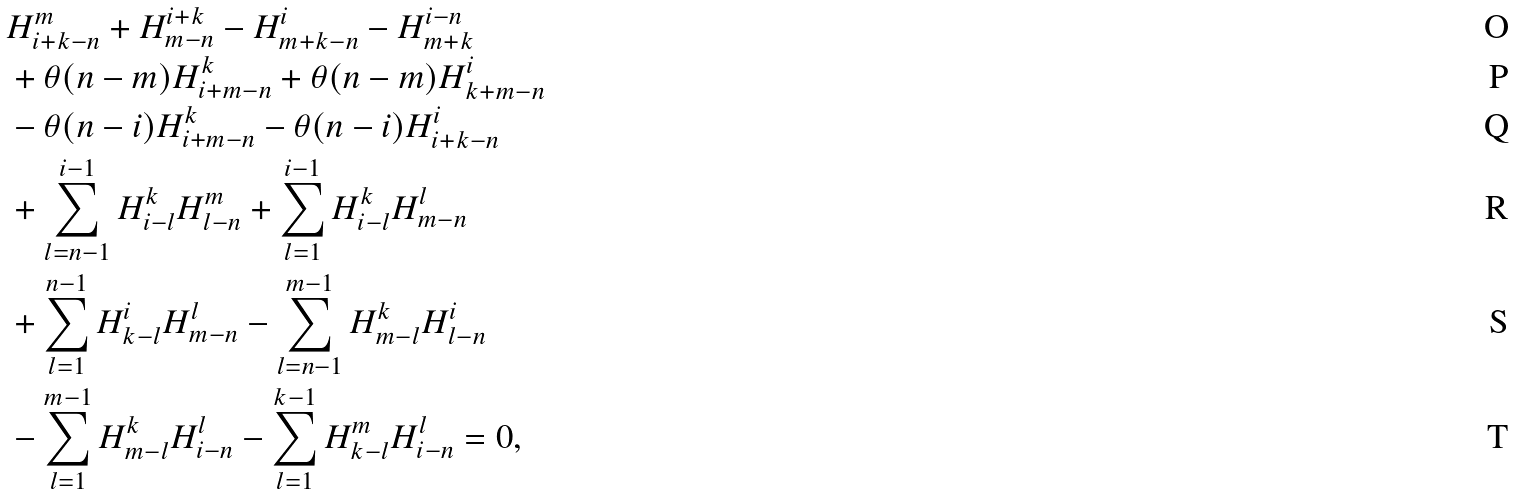Convert formula to latex. <formula><loc_0><loc_0><loc_500><loc_500>& H _ { i + k - n } ^ { m } + H _ { m - n } ^ { i + k } - H _ { m + k - n } ^ { i } - H _ { m + k } ^ { i - n } \\ & + \theta ( n - m ) H _ { i + m - n } ^ { k } + \theta ( n - m ) H _ { k + m - n } ^ { i } \\ & - \theta ( n - i ) H _ { i + m - n } ^ { k } - \theta ( n - i ) H _ { i + k - n } ^ { i } \\ & + \sum _ { l = n - 1 } ^ { i - 1 } H _ { i - l } ^ { k } H _ { l - n } ^ { m } + \sum _ { l = 1 } ^ { i - 1 } H _ { i - l } ^ { k } H _ { m - n } ^ { l } \\ & + \sum _ { l = 1 } ^ { n - 1 } H _ { k - l } ^ { i } H _ { m - n } ^ { l } - \sum _ { l = n - 1 } ^ { m - 1 } H _ { m - l } ^ { k } H _ { l - n } ^ { i } \\ & - \sum _ { l = 1 } ^ { m - 1 } H _ { m - l } ^ { k } H _ { i - n } ^ { l } - \sum _ { l = 1 } ^ { k - 1 } H _ { k - l } ^ { m } H _ { i - n } ^ { l } = 0 ,</formula> 